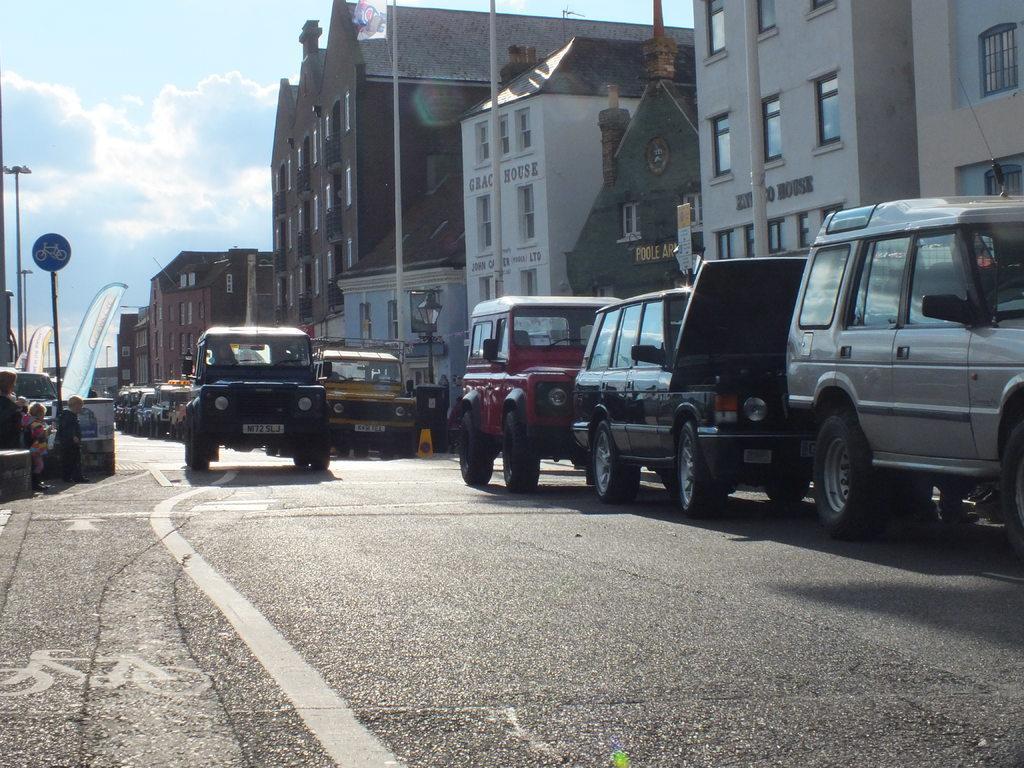Describe this image in one or two sentences. On the left side of the image we can see the poles, boards and some people are standing. In the background of the image we can see the buildings, windows, poles, vehicles, light, boards. At the bottom of the image we can see the road. At the top of the image we can see the clouds are present in the sky. 